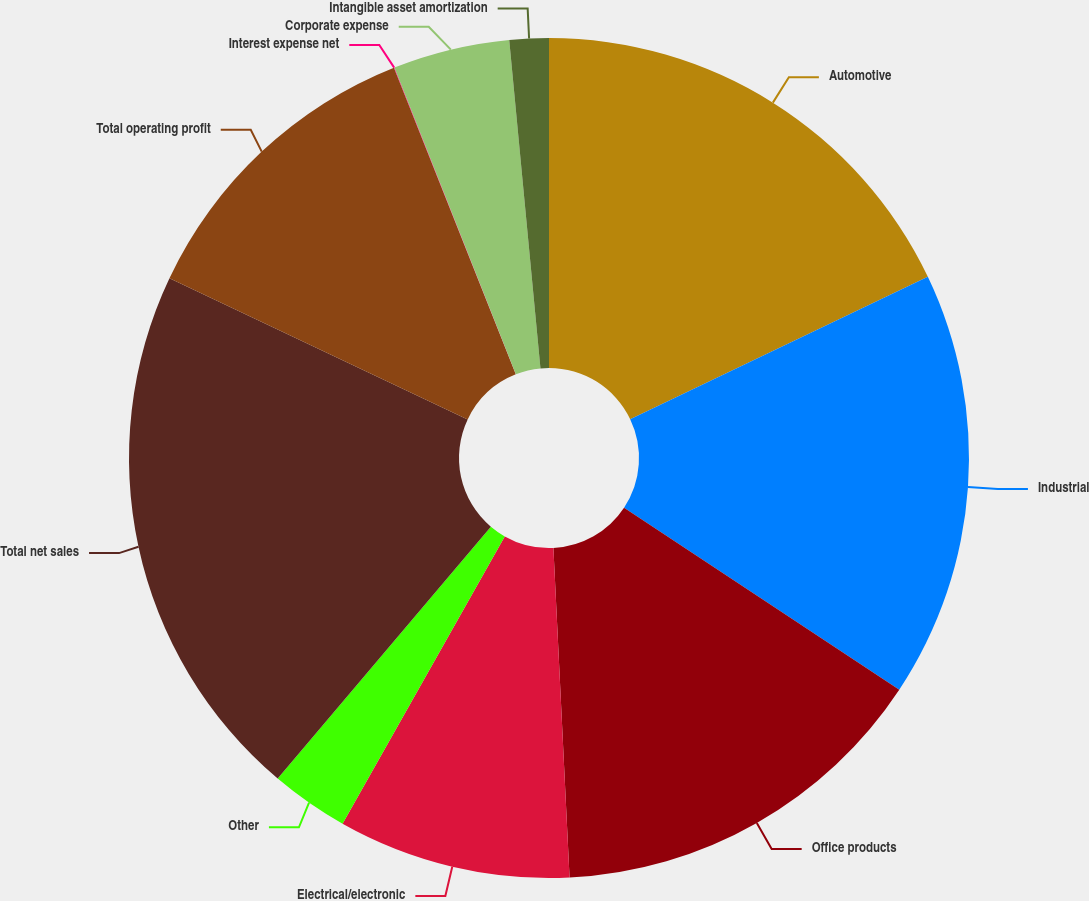<chart> <loc_0><loc_0><loc_500><loc_500><pie_chart><fcel>Automotive<fcel>Industrial<fcel>Office products<fcel>Electrical/electronic<fcel>Other<fcel>Total net sales<fcel>Total operating profit<fcel>Interest expense net<fcel>Corporate expense<fcel>Intangible asset amortization<nl><fcel>17.9%<fcel>16.41%<fcel>14.92%<fcel>8.96%<fcel>3.0%<fcel>20.87%<fcel>11.94%<fcel>0.02%<fcel>4.49%<fcel>1.51%<nl></chart> 